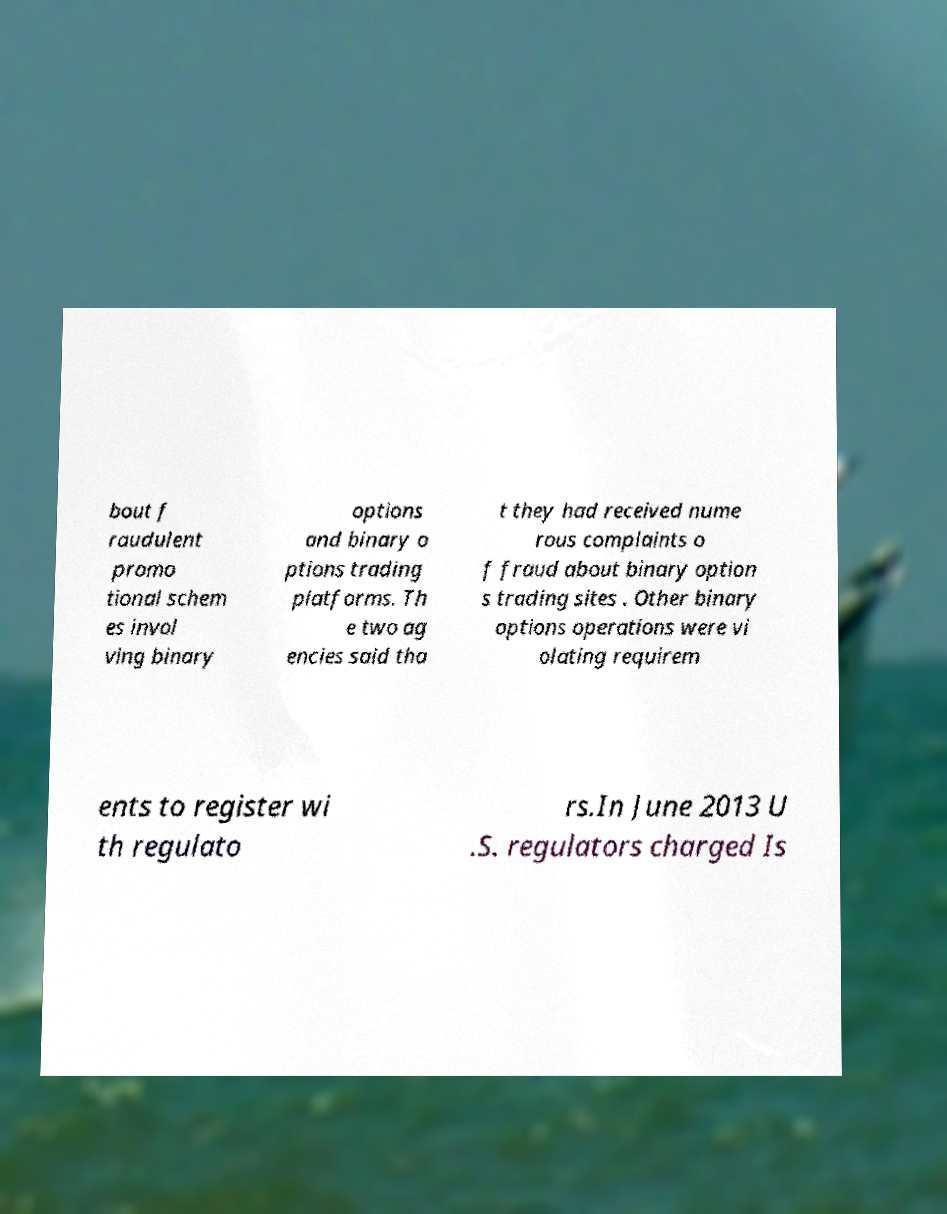Could you extract and type out the text from this image? bout f raudulent promo tional schem es invol ving binary options and binary o ptions trading platforms. Th e two ag encies said tha t they had received nume rous complaints o f fraud about binary option s trading sites . Other binary options operations were vi olating requirem ents to register wi th regulato rs.In June 2013 U .S. regulators charged Is 